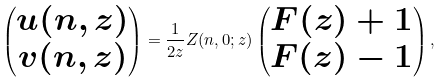Convert formula to latex. <formula><loc_0><loc_0><loc_500><loc_500>\begin{pmatrix} u ( n , z ) \\ v ( n , z ) \\ \end{pmatrix} = \frac { 1 } { 2 z } Z ( n , 0 ; z ) \begin{pmatrix} F ( z ) + 1 \\ F ( z ) - 1 \\ \end{pmatrix} ,</formula> 